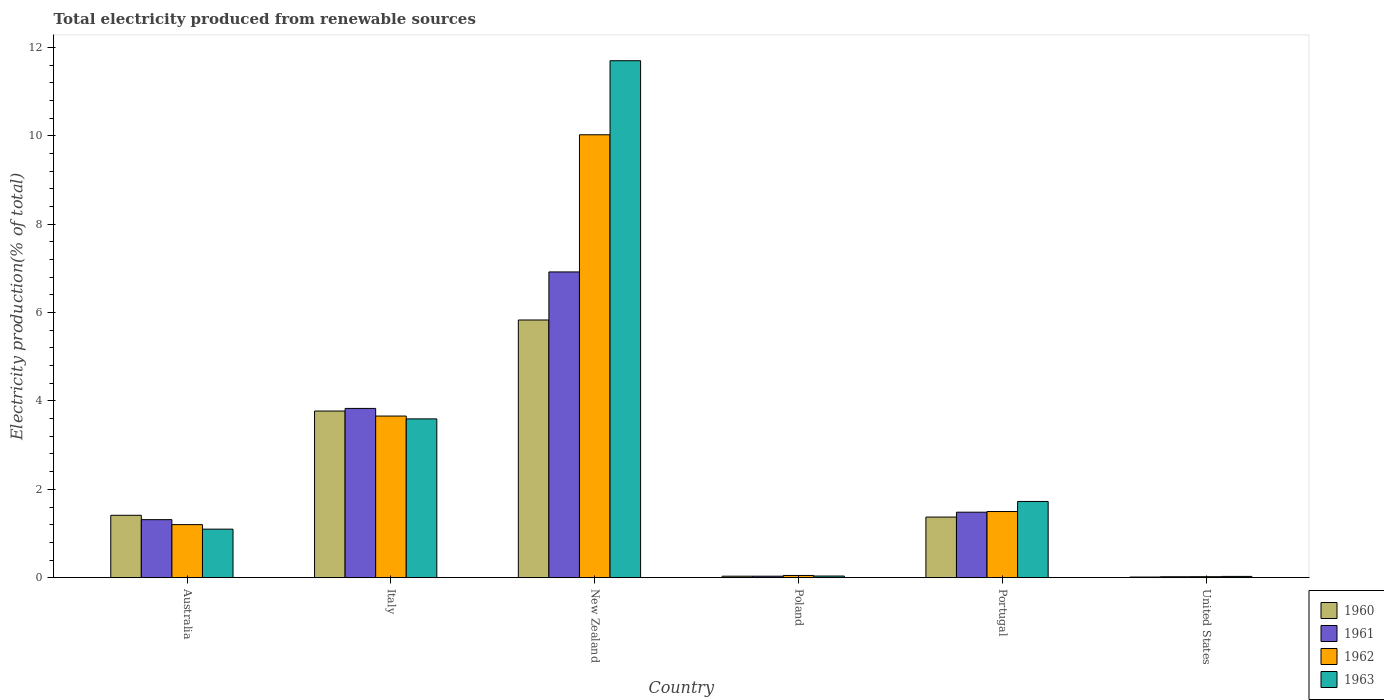How many groups of bars are there?
Offer a very short reply. 6. Are the number of bars per tick equal to the number of legend labels?
Offer a very short reply. Yes. How many bars are there on the 2nd tick from the left?
Provide a succinct answer. 4. In how many cases, is the number of bars for a given country not equal to the number of legend labels?
Keep it short and to the point. 0. What is the total electricity produced in 1962 in Poland?
Keep it short and to the point. 0.05. Across all countries, what is the maximum total electricity produced in 1963?
Provide a succinct answer. 11.7. Across all countries, what is the minimum total electricity produced in 1960?
Offer a terse response. 0.02. In which country was the total electricity produced in 1963 maximum?
Provide a short and direct response. New Zealand. In which country was the total electricity produced in 1962 minimum?
Your response must be concise. United States. What is the total total electricity produced in 1960 in the graph?
Make the answer very short. 12.44. What is the difference between the total electricity produced in 1963 in Poland and that in Portugal?
Provide a short and direct response. -1.69. What is the difference between the total electricity produced in 1963 in Poland and the total electricity produced in 1960 in Italy?
Make the answer very short. -3.73. What is the average total electricity produced in 1961 per country?
Your answer should be very brief. 2.27. What is the difference between the total electricity produced of/in 1962 and total electricity produced of/in 1960 in Australia?
Provide a succinct answer. -0.21. In how many countries, is the total electricity produced in 1963 greater than 5.6 %?
Your answer should be very brief. 1. What is the ratio of the total electricity produced in 1961 in Italy to that in Portugal?
Keep it short and to the point. 2.58. Is the total electricity produced in 1960 in Australia less than that in Italy?
Keep it short and to the point. Yes. Is the difference between the total electricity produced in 1962 in Australia and Poland greater than the difference between the total electricity produced in 1960 in Australia and Poland?
Give a very brief answer. No. What is the difference between the highest and the second highest total electricity produced in 1961?
Give a very brief answer. -2.35. What is the difference between the highest and the lowest total electricity produced in 1961?
Your answer should be compact. 6.9. In how many countries, is the total electricity produced in 1960 greater than the average total electricity produced in 1960 taken over all countries?
Keep it short and to the point. 2. Is it the case that in every country, the sum of the total electricity produced in 1963 and total electricity produced in 1961 is greater than the sum of total electricity produced in 1962 and total electricity produced in 1960?
Ensure brevity in your answer.  No. What does the 3rd bar from the left in Poland represents?
Provide a succinct answer. 1962. Is it the case that in every country, the sum of the total electricity produced in 1963 and total electricity produced in 1962 is greater than the total electricity produced in 1960?
Keep it short and to the point. Yes. How many bars are there?
Give a very brief answer. 24. How many countries are there in the graph?
Offer a terse response. 6. Are the values on the major ticks of Y-axis written in scientific E-notation?
Offer a terse response. No. How are the legend labels stacked?
Offer a very short reply. Vertical. What is the title of the graph?
Your answer should be compact. Total electricity produced from renewable sources. What is the label or title of the X-axis?
Provide a succinct answer. Country. What is the label or title of the Y-axis?
Make the answer very short. Electricity production(% of total). What is the Electricity production(% of total) in 1960 in Australia?
Give a very brief answer. 1.41. What is the Electricity production(% of total) in 1961 in Australia?
Offer a terse response. 1.31. What is the Electricity production(% of total) in 1962 in Australia?
Ensure brevity in your answer.  1.2. What is the Electricity production(% of total) in 1963 in Australia?
Your answer should be compact. 1.1. What is the Electricity production(% of total) of 1960 in Italy?
Ensure brevity in your answer.  3.77. What is the Electricity production(% of total) of 1961 in Italy?
Ensure brevity in your answer.  3.83. What is the Electricity production(% of total) of 1962 in Italy?
Your answer should be compact. 3.66. What is the Electricity production(% of total) in 1963 in Italy?
Your answer should be very brief. 3.59. What is the Electricity production(% of total) of 1960 in New Zealand?
Offer a very short reply. 5.83. What is the Electricity production(% of total) of 1961 in New Zealand?
Your answer should be very brief. 6.92. What is the Electricity production(% of total) in 1962 in New Zealand?
Keep it short and to the point. 10.02. What is the Electricity production(% of total) in 1963 in New Zealand?
Give a very brief answer. 11.7. What is the Electricity production(% of total) in 1960 in Poland?
Give a very brief answer. 0.03. What is the Electricity production(% of total) of 1961 in Poland?
Your answer should be compact. 0.03. What is the Electricity production(% of total) of 1962 in Poland?
Offer a terse response. 0.05. What is the Electricity production(% of total) of 1963 in Poland?
Your answer should be very brief. 0.04. What is the Electricity production(% of total) of 1960 in Portugal?
Make the answer very short. 1.37. What is the Electricity production(% of total) in 1961 in Portugal?
Ensure brevity in your answer.  1.48. What is the Electricity production(% of total) in 1962 in Portugal?
Provide a succinct answer. 1.5. What is the Electricity production(% of total) of 1963 in Portugal?
Make the answer very short. 1.73. What is the Electricity production(% of total) of 1960 in United States?
Provide a short and direct response. 0.02. What is the Electricity production(% of total) in 1961 in United States?
Give a very brief answer. 0.02. What is the Electricity production(% of total) of 1962 in United States?
Ensure brevity in your answer.  0.02. What is the Electricity production(% of total) in 1963 in United States?
Ensure brevity in your answer.  0.03. Across all countries, what is the maximum Electricity production(% of total) in 1960?
Keep it short and to the point. 5.83. Across all countries, what is the maximum Electricity production(% of total) in 1961?
Keep it short and to the point. 6.92. Across all countries, what is the maximum Electricity production(% of total) of 1962?
Give a very brief answer. 10.02. Across all countries, what is the maximum Electricity production(% of total) of 1963?
Make the answer very short. 11.7. Across all countries, what is the minimum Electricity production(% of total) in 1960?
Offer a terse response. 0.02. Across all countries, what is the minimum Electricity production(% of total) of 1961?
Offer a very short reply. 0.02. Across all countries, what is the minimum Electricity production(% of total) in 1962?
Your answer should be very brief. 0.02. Across all countries, what is the minimum Electricity production(% of total) of 1963?
Your response must be concise. 0.03. What is the total Electricity production(% of total) in 1960 in the graph?
Provide a short and direct response. 12.44. What is the total Electricity production(% of total) in 1961 in the graph?
Provide a short and direct response. 13.6. What is the total Electricity production(% of total) of 1962 in the graph?
Your answer should be very brief. 16.46. What is the total Electricity production(% of total) of 1963 in the graph?
Your answer should be compact. 18.19. What is the difference between the Electricity production(% of total) in 1960 in Australia and that in Italy?
Your answer should be very brief. -2.36. What is the difference between the Electricity production(% of total) of 1961 in Australia and that in Italy?
Your response must be concise. -2.52. What is the difference between the Electricity production(% of total) of 1962 in Australia and that in Italy?
Your response must be concise. -2.46. What is the difference between the Electricity production(% of total) of 1963 in Australia and that in Italy?
Ensure brevity in your answer.  -2.5. What is the difference between the Electricity production(% of total) of 1960 in Australia and that in New Zealand?
Keep it short and to the point. -4.42. What is the difference between the Electricity production(% of total) of 1961 in Australia and that in New Zealand?
Make the answer very short. -5.61. What is the difference between the Electricity production(% of total) in 1962 in Australia and that in New Zealand?
Keep it short and to the point. -8.82. What is the difference between the Electricity production(% of total) in 1963 in Australia and that in New Zealand?
Your response must be concise. -10.6. What is the difference between the Electricity production(% of total) of 1960 in Australia and that in Poland?
Your answer should be very brief. 1.38. What is the difference between the Electricity production(% of total) in 1961 in Australia and that in Poland?
Offer a very short reply. 1.28. What is the difference between the Electricity production(% of total) in 1962 in Australia and that in Poland?
Your answer should be very brief. 1.15. What is the difference between the Electricity production(% of total) of 1963 in Australia and that in Poland?
Your answer should be compact. 1.06. What is the difference between the Electricity production(% of total) in 1960 in Australia and that in Portugal?
Provide a succinct answer. 0.04. What is the difference between the Electricity production(% of total) in 1961 in Australia and that in Portugal?
Your response must be concise. -0.17. What is the difference between the Electricity production(% of total) in 1962 in Australia and that in Portugal?
Offer a very short reply. -0.3. What is the difference between the Electricity production(% of total) of 1963 in Australia and that in Portugal?
Your answer should be very brief. -0.63. What is the difference between the Electricity production(% of total) of 1960 in Australia and that in United States?
Ensure brevity in your answer.  1.4. What is the difference between the Electricity production(% of total) of 1961 in Australia and that in United States?
Provide a short and direct response. 1.29. What is the difference between the Electricity production(% of total) of 1962 in Australia and that in United States?
Ensure brevity in your answer.  1.18. What is the difference between the Electricity production(% of total) of 1963 in Australia and that in United States?
Offer a terse response. 1.07. What is the difference between the Electricity production(% of total) in 1960 in Italy and that in New Zealand?
Your answer should be very brief. -2.06. What is the difference between the Electricity production(% of total) in 1961 in Italy and that in New Zealand?
Provide a short and direct response. -3.09. What is the difference between the Electricity production(% of total) of 1962 in Italy and that in New Zealand?
Provide a succinct answer. -6.37. What is the difference between the Electricity production(% of total) in 1963 in Italy and that in New Zealand?
Ensure brevity in your answer.  -8.11. What is the difference between the Electricity production(% of total) of 1960 in Italy and that in Poland?
Your answer should be compact. 3.74. What is the difference between the Electricity production(% of total) of 1961 in Italy and that in Poland?
Keep it short and to the point. 3.8. What is the difference between the Electricity production(% of total) of 1962 in Italy and that in Poland?
Provide a short and direct response. 3.61. What is the difference between the Electricity production(% of total) in 1963 in Italy and that in Poland?
Make the answer very short. 3.56. What is the difference between the Electricity production(% of total) of 1960 in Italy and that in Portugal?
Your answer should be compact. 2.4. What is the difference between the Electricity production(% of total) in 1961 in Italy and that in Portugal?
Your response must be concise. 2.35. What is the difference between the Electricity production(% of total) in 1962 in Italy and that in Portugal?
Provide a succinct answer. 2.16. What is the difference between the Electricity production(% of total) of 1963 in Italy and that in Portugal?
Provide a succinct answer. 1.87. What is the difference between the Electricity production(% of total) of 1960 in Italy and that in United States?
Your response must be concise. 3.76. What is the difference between the Electricity production(% of total) of 1961 in Italy and that in United States?
Provide a succinct answer. 3.81. What is the difference between the Electricity production(% of total) of 1962 in Italy and that in United States?
Make the answer very short. 3.64. What is the difference between the Electricity production(% of total) of 1963 in Italy and that in United States?
Offer a very short reply. 3.56. What is the difference between the Electricity production(% of total) in 1960 in New Zealand and that in Poland?
Provide a short and direct response. 5.8. What is the difference between the Electricity production(% of total) of 1961 in New Zealand and that in Poland?
Offer a very short reply. 6.89. What is the difference between the Electricity production(% of total) of 1962 in New Zealand and that in Poland?
Provide a short and direct response. 9.97. What is the difference between the Electricity production(% of total) of 1963 in New Zealand and that in Poland?
Offer a very short reply. 11.66. What is the difference between the Electricity production(% of total) of 1960 in New Zealand and that in Portugal?
Offer a very short reply. 4.46. What is the difference between the Electricity production(% of total) in 1961 in New Zealand and that in Portugal?
Your response must be concise. 5.44. What is the difference between the Electricity production(% of total) in 1962 in New Zealand and that in Portugal?
Keep it short and to the point. 8.53. What is the difference between the Electricity production(% of total) of 1963 in New Zealand and that in Portugal?
Your answer should be very brief. 9.97. What is the difference between the Electricity production(% of total) in 1960 in New Zealand and that in United States?
Provide a succinct answer. 5.82. What is the difference between the Electricity production(% of total) of 1961 in New Zealand and that in United States?
Provide a succinct answer. 6.9. What is the difference between the Electricity production(% of total) of 1962 in New Zealand and that in United States?
Provide a short and direct response. 10. What is the difference between the Electricity production(% of total) of 1963 in New Zealand and that in United States?
Provide a short and direct response. 11.67. What is the difference between the Electricity production(% of total) in 1960 in Poland and that in Portugal?
Your response must be concise. -1.34. What is the difference between the Electricity production(% of total) of 1961 in Poland and that in Portugal?
Provide a short and direct response. -1.45. What is the difference between the Electricity production(% of total) of 1962 in Poland and that in Portugal?
Your answer should be very brief. -1.45. What is the difference between the Electricity production(% of total) in 1963 in Poland and that in Portugal?
Provide a short and direct response. -1.69. What is the difference between the Electricity production(% of total) in 1960 in Poland and that in United States?
Your response must be concise. 0.02. What is the difference between the Electricity production(% of total) in 1961 in Poland and that in United States?
Provide a short and direct response. 0.01. What is the difference between the Electricity production(% of total) of 1962 in Poland and that in United States?
Your answer should be very brief. 0.03. What is the difference between the Electricity production(% of total) in 1963 in Poland and that in United States?
Your response must be concise. 0.01. What is the difference between the Electricity production(% of total) in 1960 in Portugal and that in United States?
Your response must be concise. 1.36. What is the difference between the Electricity production(% of total) of 1961 in Portugal and that in United States?
Your response must be concise. 1.46. What is the difference between the Electricity production(% of total) of 1962 in Portugal and that in United States?
Ensure brevity in your answer.  1.48. What is the difference between the Electricity production(% of total) in 1963 in Portugal and that in United States?
Your response must be concise. 1.7. What is the difference between the Electricity production(% of total) of 1960 in Australia and the Electricity production(% of total) of 1961 in Italy?
Provide a succinct answer. -2.42. What is the difference between the Electricity production(% of total) in 1960 in Australia and the Electricity production(% of total) in 1962 in Italy?
Your answer should be very brief. -2.25. What is the difference between the Electricity production(% of total) in 1960 in Australia and the Electricity production(% of total) in 1963 in Italy?
Keep it short and to the point. -2.18. What is the difference between the Electricity production(% of total) of 1961 in Australia and the Electricity production(% of total) of 1962 in Italy?
Offer a terse response. -2.34. What is the difference between the Electricity production(% of total) of 1961 in Australia and the Electricity production(% of total) of 1963 in Italy?
Your answer should be compact. -2.28. What is the difference between the Electricity production(% of total) in 1962 in Australia and the Electricity production(% of total) in 1963 in Italy?
Provide a short and direct response. -2.39. What is the difference between the Electricity production(% of total) in 1960 in Australia and the Electricity production(% of total) in 1961 in New Zealand?
Provide a succinct answer. -5.51. What is the difference between the Electricity production(% of total) in 1960 in Australia and the Electricity production(% of total) in 1962 in New Zealand?
Keep it short and to the point. -8.61. What is the difference between the Electricity production(% of total) in 1960 in Australia and the Electricity production(% of total) in 1963 in New Zealand?
Provide a succinct answer. -10.29. What is the difference between the Electricity production(% of total) of 1961 in Australia and the Electricity production(% of total) of 1962 in New Zealand?
Give a very brief answer. -8.71. What is the difference between the Electricity production(% of total) of 1961 in Australia and the Electricity production(% of total) of 1963 in New Zealand?
Keep it short and to the point. -10.39. What is the difference between the Electricity production(% of total) of 1962 in Australia and the Electricity production(% of total) of 1963 in New Zealand?
Offer a very short reply. -10.5. What is the difference between the Electricity production(% of total) in 1960 in Australia and the Electricity production(% of total) in 1961 in Poland?
Offer a very short reply. 1.38. What is the difference between the Electricity production(% of total) in 1960 in Australia and the Electricity production(% of total) in 1962 in Poland?
Ensure brevity in your answer.  1.36. What is the difference between the Electricity production(% of total) of 1960 in Australia and the Electricity production(% of total) of 1963 in Poland?
Ensure brevity in your answer.  1.37. What is the difference between the Electricity production(% of total) in 1961 in Australia and the Electricity production(% of total) in 1962 in Poland?
Keep it short and to the point. 1.26. What is the difference between the Electricity production(% of total) in 1961 in Australia and the Electricity production(% of total) in 1963 in Poland?
Your response must be concise. 1.28. What is the difference between the Electricity production(% of total) in 1962 in Australia and the Electricity production(% of total) in 1963 in Poland?
Provide a short and direct response. 1.16. What is the difference between the Electricity production(% of total) of 1960 in Australia and the Electricity production(% of total) of 1961 in Portugal?
Keep it short and to the point. -0.07. What is the difference between the Electricity production(% of total) in 1960 in Australia and the Electricity production(% of total) in 1962 in Portugal?
Give a very brief answer. -0.09. What is the difference between the Electricity production(% of total) of 1960 in Australia and the Electricity production(% of total) of 1963 in Portugal?
Your response must be concise. -0.31. What is the difference between the Electricity production(% of total) in 1961 in Australia and the Electricity production(% of total) in 1962 in Portugal?
Ensure brevity in your answer.  -0.18. What is the difference between the Electricity production(% of total) of 1961 in Australia and the Electricity production(% of total) of 1963 in Portugal?
Provide a succinct answer. -0.41. What is the difference between the Electricity production(% of total) in 1962 in Australia and the Electricity production(% of total) in 1963 in Portugal?
Provide a short and direct response. -0.52. What is the difference between the Electricity production(% of total) in 1960 in Australia and the Electricity production(% of total) in 1961 in United States?
Provide a short and direct response. 1.39. What is the difference between the Electricity production(% of total) of 1960 in Australia and the Electricity production(% of total) of 1962 in United States?
Offer a terse response. 1.39. What is the difference between the Electricity production(% of total) in 1960 in Australia and the Electricity production(% of total) in 1963 in United States?
Keep it short and to the point. 1.38. What is the difference between the Electricity production(% of total) in 1961 in Australia and the Electricity production(% of total) in 1962 in United States?
Provide a succinct answer. 1.29. What is the difference between the Electricity production(% of total) of 1961 in Australia and the Electricity production(% of total) of 1963 in United States?
Offer a terse response. 1.28. What is the difference between the Electricity production(% of total) in 1962 in Australia and the Electricity production(% of total) in 1963 in United States?
Keep it short and to the point. 1.17. What is the difference between the Electricity production(% of total) of 1960 in Italy and the Electricity production(% of total) of 1961 in New Zealand?
Make the answer very short. -3.15. What is the difference between the Electricity production(% of total) in 1960 in Italy and the Electricity production(% of total) in 1962 in New Zealand?
Ensure brevity in your answer.  -6.25. What is the difference between the Electricity production(% of total) in 1960 in Italy and the Electricity production(% of total) in 1963 in New Zealand?
Offer a very short reply. -7.93. What is the difference between the Electricity production(% of total) of 1961 in Italy and the Electricity production(% of total) of 1962 in New Zealand?
Provide a short and direct response. -6.19. What is the difference between the Electricity production(% of total) in 1961 in Italy and the Electricity production(% of total) in 1963 in New Zealand?
Keep it short and to the point. -7.87. What is the difference between the Electricity production(% of total) of 1962 in Italy and the Electricity production(% of total) of 1963 in New Zealand?
Make the answer very short. -8.04. What is the difference between the Electricity production(% of total) of 1960 in Italy and the Electricity production(% of total) of 1961 in Poland?
Your response must be concise. 3.74. What is the difference between the Electricity production(% of total) in 1960 in Italy and the Electricity production(% of total) in 1962 in Poland?
Your response must be concise. 3.72. What is the difference between the Electricity production(% of total) in 1960 in Italy and the Electricity production(% of total) in 1963 in Poland?
Make the answer very short. 3.73. What is the difference between the Electricity production(% of total) in 1961 in Italy and the Electricity production(% of total) in 1962 in Poland?
Your response must be concise. 3.78. What is the difference between the Electricity production(% of total) in 1961 in Italy and the Electricity production(% of total) in 1963 in Poland?
Your answer should be very brief. 3.79. What is the difference between the Electricity production(% of total) in 1962 in Italy and the Electricity production(% of total) in 1963 in Poland?
Offer a terse response. 3.62. What is the difference between the Electricity production(% of total) of 1960 in Italy and the Electricity production(% of total) of 1961 in Portugal?
Ensure brevity in your answer.  2.29. What is the difference between the Electricity production(% of total) of 1960 in Italy and the Electricity production(% of total) of 1962 in Portugal?
Make the answer very short. 2.27. What is the difference between the Electricity production(% of total) in 1960 in Italy and the Electricity production(% of total) in 1963 in Portugal?
Keep it short and to the point. 2.05. What is the difference between the Electricity production(% of total) in 1961 in Italy and the Electricity production(% of total) in 1962 in Portugal?
Provide a succinct answer. 2.33. What is the difference between the Electricity production(% of total) of 1961 in Italy and the Electricity production(% of total) of 1963 in Portugal?
Offer a terse response. 2.11. What is the difference between the Electricity production(% of total) of 1962 in Italy and the Electricity production(% of total) of 1963 in Portugal?
Give a very brief answer. 1.93. What is the difference between the Electricity production(% of total) of 1960 in Italy and the Electricity production(% of total) of 1961 in United States?
Offer a terse response. 3.75. What is the difference between the Electricity production(% of total) in 1960 in Italy and the Electricity production(% of total) in 1962 in United States?
Your answer should be compact. 3.75. What is the difference between the Electricity production(% of total) in 1960 in Italy and the Electricity production(% of total) in 1963 in United States?
Give a very brief answer. 3.74. What is the difference between the Electricity production(% of total) in 1961 in Italy and the Electricity production(% of total) in 1962 in United States?
Provide a succinct answer. 3.81. What is the difference between the Electricity production(% of total) of 1961 in Italy and the Electricity production(% of total) of 1963 in United States?
Make the answer very short. 3.8. What is the difference between the Electricity production(% of total) in 1962 in Italy and the Electricity production(% of total) in 1963 in United States?
Offer a very short reply. 3.63. What is the difference between the Electricity production(% of total) in 1960 in New Zealand and the Electricity production(% of total) in 1961 in Poland?
Make the answer very short. 5.8. What is the difference between the Electricity production(% of total) in 1960 in New Zealand and the Electricity production(% of total) in 1962 in Poland?
Offer a terse response. 5.78. What is the difference between the Electricity production(% of total) of 1960 in New Zealand and the Electricity production(% of total) of 1963 in Poland?
Keep it short and to the point. 5.79. What is the difference between the Electricity production(% of total) of 1961 in New Zealand and the Electricity production(% of total) of 1962 in Poland?
Provide a short and direct response. 6.87. What is the difference between the Electricity production(% of total) of 1961 in New Zealand and the Electricity production(% of total) of 1963 in Poland?
Provide a short and direct response. 6.88. What is the difference between the Electricity production(% of total) of 1962 in New Zealand and the Electricity production(% of total) of 1963 in Poland?
Ensure brevity in your answer.  9.99. What is the difference between the Electricity production(% of total) of 1960 in New Zealand and the Electricity production(% of total) of 1961 in Portugal?
Your response must be concise. 4.35. What is the difference between the Electricity production(% of total) of 1960 in New Zealand and the Electricity production(% of total) of 1962 in Portugal?
Your response must be concise. 4.33. What is the difference between the Electricity production(% of total) in 1960 in New Zealand and the Electricity production(% of total) in 1963 in Portugal?
Your answer should be very brief. 4.11. What is the difference between the Electricity production(% of total) in 1961 in New Zealand and the Electricity production(% of total) in 1962 in Portugal?
Ensure brevity in your answer.  5.42. What is the difference between the Electricity production(% of total) of 1961 in New Zealand and the Electricity production(% of total) of 1963 in Portugal?
Offer a terse response. 5.19. What is the difference between the Electricity production(% of total) in 1962 in New Zealand and the Electricity production(% of total) in 1963 in Portugal?
Your answer should be very brief. 8.3. What is the difference between the Electricity production(% of total) in 1960 in New Zealand and the Electricity production(% of total) in 1961 in United States?
Give a very brief answer. 5.81. What is the difference between the Electricity production(% of total) in 1960 in New Zealand and the Electricity production(% of total) in 1962 in United States?
Give a very brief answer. 5.81. What is the difference between the Electricity production(% of total) in 1960 in New Zealand and the Electricity production(% of total) in 1963 in United States?
Make the answer very short. 5.8. What is the difference between the Electricity production(% of total) in 1961 in New Zealand and the Electricity production(% of total) in 1962 in United States?
Ensure brevity in your answer.  6.9. What is the difference between the Electricity production(% of total) in 1961 in New Zealand and the Electricity production(% of total) in 1963 in United States?
Provide a succinct answer. 6.89. What is the difference between the Electricity production(% of total) in 1962 in New Zealand and the Electricity production(% of total) in 1963 in United States?
Offer a terse response. 10. What is the difference between the Electricity production(% of total) in 1960 in Poland and the Electricity production(% of total) in 1961 in Portugal?
Keep it short and to the point. -1.45. What is the difference between the Electricity production(% of total) of 1960 in Poland and the Electricity production(% of total) of 1962 in Portugal?
Keep it short and to the point. -1.46. What is the difference between the Electricity production(% of total) of 1960 in Poland and the Electricity production(% of total) of 1963 in Portugal?
Give a very brief answer. -1.69. What is the difference between the Electricity production(% of total) in 1961 in Poland and the Electricity production(% of total) in 1962 in Portugal?
Make the answer very short. -1.46. What is the difference between the Electricity production(% of total) of 1961 in Poland and the Electricity production(% of total) of 1963 in Portugal?
Your answer should be very brief. -1.69. What is the difference between the Electricity production(% of total) in 1962 in Poland and the Electricity production(% of total) in 1963 in Portugal?
Offer a very short reply. -1.67. What is the difference between the Electricity production(% of total) of 1960 in Poland and the Electricity production(% of total) of 1961 in United States?
Provide a succinct answer. 0.01. What is the difference between the Electricity production(% of total) in 1960 in Poland and the Electricity production(% of total) in 1962 in United States?
Offer a very short reply. 0.01. What is the difference between the Electricity production(% of total) of 1960 in Poland and the Electricity production(% of total) of 1963 in United States?
Your response must be concise. 0. What is the difference between the Electricity production(% of total) of 1961 in Poland and the Electricity production(% of total) of 1962 in United States?
Offer a terse response. 0.01. What is the difference between the Electricity production(% of total) of 1961 in Poland and the Electricity production(% of total) of 1963 in United States?
Provide a succinct answer. 0. What is the difference between the Electricity production(% of total) in 1962 in Poland and the Electricity production(% of total) in 1963 in United States?
Provide a succinct answer. 0.02. What is the difference between the Electricity production(% of total) in 1960 in Portugal and the Electricity production(% of total) in 1961 in United States?
Your response must be concise. 1.35. What is the difference between the Electricity production(% of total) in 1960 in Portugal and the Electricity production(% of total) in 1962 in United States?
Make the answer very short. 1.35. What is the difference between the Electricity production(% of total) of 1960 in Portugal and the Electricity production(% of total) of 1963 in United States?
Provide a succinct answer. 1.34. What is the difference between the Electricity production(% of total) in 1961 in Portugal and the Electricity production(% of total) in 1962 in United States?
Give a very brief answer. 1.46. What is the difference between the Electricity production(% of total) in 1961 in Portugal and the Electricity production(% of total) in 1963 in United States?
Make the answer very short. 1.45. What is the difference between the Electricity production(% of total) in 1962 in Portugal and the Electricity production(% of total) in 1963 in United States?
Your answer should be compact. 1.47. What is the average Electricity production(% of total) of 1960 per country?
Your answer should be compact. 2.07. What is the average Electricity production(% of total) of 1961 per country?
Keep it short and to the point. 2.27. What is the average Electricity production(% of total) of 1962 per country?
Your answer should be compact. 2.74. What is the average Electricity production(% of total) in 1963 per country?
Ensure brevity in your answer.  3.03. What is the difference between the Electricity production(% of total) in 1960 and Electricity production(% of total) in 1961 in Australia?
Offer a terse response. 0.1. What is the difference between the Electricity production(% of total) of 1960 and Electricity production(% of total) of 1962 in Australia?
Provide a succinct answer. 0.21. What is the difference between the Electricity production(% of total) of 1960 and Electricity production(% of total) of 1963 in Australia?
Provide a succinct answer. 0.31. What is the difference between the Electricity production(% of total) in 1961 and Electricity production(% of total) in 1962 in Australia?
Offer a terse response. 0.11. What is the difference between the Electricity production(% of total) of 1961 and Electricity production(% of total) of 1963 in Australia?
Your answer should be compact. 0.21. What is the difference between the Electricity production(% of total) of 1962 and Electricity production(% of total) of 1963 in Australia?
Provide a short and direct response. 0.1. What is the difference between the Electricity production(% of total) in 1960 and Electricity production(% of total) in 1961 in Italy?
Your response must be concise. -0.06. What is the difference between the Electricity production(% of total) in 1960 and Electricity production(% of total) in 1962 in Italy?
Your answer should be very brief. 0.11. What is the difference between the Electricity production(% of total) of 1960 and Electricity production(% of total) of 1963 in Italy?
Your answer should be compact. 0.18. What is the difference between the Electricity production(% of total) in 1961 and Electricity production(% of total) in 1962 in Italy?
Offer a terse response. 0.17. What is the difference between the Electricity production(% of total) in 1961 and Electricity production(% of total) in 1963 in Italy?
Give a very brief answer. 0.24. What is the difference between the Electricity production(% of total) in 1962 and Electricity production(% of total) in 1963 in Italy?
Provide a succinct answer. 0.06. What is the difference between the Electricity production(% of total) in 1960 and Electricity production(% of total) in 1961 in New Zealand?
Provide a short and direct response. -1.09. What is the difference between the Electricity production(% of total) in 1960 and Electricity production(% of total) in 1962 in New Zealand?
Provide a succinct answer. -4.19. What is the difference between the Electricity production(% of total) of 1960 and Electricity production(% of total) of 1963 in New Zealand?
Give a very brief answer. -5.87. What is the difference between the Electricity production(% of total) in 1961 and Electricity production(% of total) in 1962 in New Zealand?
Give a very brief answer. -3.1. What is the difference between the Electricity production(% of total) of 1961 and Electricity production(% of total) of 1963 in New Zealand?
Provide a short and direct response. -4.78. What is the difference between the Electricity production(% of total) of 1962 and Electricity production(% of total) of 1963 in New Zealand?
Your answer should be compact. -1.68. What is the difference between the Electricity production(% of total) of 1960 and Electricity production(% of total) of 1962 in Poland?
Offer a very short reply. -0.02. What is the difference between the Electricity production(% of total) of 1960 and Electricity production(% of total) of 1963 in Poland?
Make the answer very short. -0. What is the difference between the Electricity production(% of total) in 1961 and Electricity production(% of total) in 1962 in Poland?
Provide a short and direct response. -0.02. What is the difference between the Electricity production(% of total) of 1961 and Electricity production(% of total) of 1963 in Poland?
Keep it short and to the point. -0. What is the difference between the Electricity production(% of total) in 1962 and Electricity production(% of total) in 1963 in Poland?
Give a very brief answer. 0.01. What is the difference between the Electricity production(% of total) in 1960 and Electricity production(% of total) in 1961 in Portugal?
Ensure brevity in your answer.  -0.11. What is the difference between the Electricity production(% of total) of 1960 and Electricity production(% of total) of 1962 in Portugal?
Offer a terse response. -0.13. What is the difference between the Electricity production(% of total) in 1960 and Electricity production(% of total) in 1963 in Portugal?
Offer a very short reply. -0.35. What is the difference between the Electricity production(% of total) of 1961 and Electricity production(% of total) of 1962 in Portugal?
Your answer should be very brief. -0.02. What is the difference between the Electricity production(% of total) of 1961 and Electricity production(% of total) of 1963 in Portugal?
Offer a very short reply. -0.24. What is the difference between the Electricity production(% of total) of 1962 and Electricity production(% of total) of 1963 in Portugal?
Your answer should be compact. -0.23. What is the difference between the Electricity production(% of total) in 1960 and Electricity production(% of total) in 1961 in United States?
Offer a very short reply. -0.01. What is the difference between the Electricity production(% of total) of 1960 and Electricity production(% of total) of 1962 in United States?
Provide a succinct answer. -0.01. What is the difference between the Electricity production(% of total) of 1960 and Electricity production(% of total) of 1963 in United States?
Give a very brief answer. -0.01. What is the difference between the Electricity production(% of total) of 1961 and Electricity production(% of total) of 1962 in United States?
Your response must be concise. -0. What is the difference between the Electricity production(% of total) of 1961 and Electricity production(% of total) of 1963 in United States?
Your answer should be compact. -0.01. What is the difference between the Electricity production(% of total) of 1962 and Electricity production(% of total) of 1963 in United States?
Your response must be concise. -0.01. What is the ratio of the Electricity production(% of total) in 1960 in Australia to that in Italy?
Give a very brief answer. 0.37. What is the ratio of the Electricity production(% of total) of 1961 in Australia to that in Italy?
Keep it short and to the point. 0.34. What is the ratio of the Electricity production(% of total) in 1962 in Australia to that in Italy?
Give a very brief answer. 0.33. What is the ratio of the Electricity production(% of total) in 1963 in Australia to that in Italy?
Offer a very short reply. 0.31. What is the ratio of the Electricity production(% of total) of 1960 in Australia to that in New Zealand?
Provide a short and direct response. 0.24. What is the ratio of the Electricity production(% of total) of 1961 in Australia to that in New Zealand?
Your response must be concise. 0.19. What is the ratio of the Electricity production(% of total) in 1962 in Australia to that in New Zealand?
Ensure brevity in your answer.  0.12. What is the ratio of the Electricity production(% of total) of 1963 in Australia to that in New Zealand?
Your answer should be compact. 0.09. What is the ratio of the Electricity production(% of total) in 1960 in Australia to that in Poland?
Your response must be concise. 41.37. What is the ratio of the Electricity production(% of total) in 1961 in Australia to that in Poland?
Your response must be concise. 38.51. What is the ratio of the Electricity production(% of total) of 1962 in Australia to that in Poland?
Your answer should be compact. 23.61. What is the ratio of the Electricity production(% of total) in 1963 in Australia to that in Poland?
Your answer should be very brief. 29. What is the ratio of the Electricity production(% of total) in 1960 in Australia to that in Portugal?
Ensure brevity in your answer.  1.03. What is the ratio of the Electricity production(% of total) in 1961 in Australia to that in Portugal?
Ensure brevity in your answer.  0.89. What is the ratio of the Electricity production(% of total) in 1962 in Australia to that in Portugal?
Offer a terse response. 0.8. What is the ratio of the Electricity production(% of total) in 1963 in Australia to that in Portugal?
Provide a succinct answer. 0.64. What is the ratio of the Electricity production(% of total) of 1960 in Australia to that in United States?
Your answer should be compact. 92.6. What is the ratio of the Electricity production(% of total) in 1961 in Australia to that in United States?
Give a very brief answer. 61. What is the ratio of the Electricity production(% of total) in 1962 in Australia to that in United States?
Ensure brevity in your answer.  52.74. What is the ratio of the Electricity production(% of total) in 1963 in Australia to that in United States?
Provide a short and direct response. 37.34. What is the ratio of the Electricity production(% of total) of 1960 in Italy to that in New Zealand?
Ensure brevity in your answer.  0.65. What is the ratio of the Electricity production(% of total) in 1961 in Italy to that in New Zealand?
Keep it short and to the point. 0.55. What is the ratio of the Electricity production(% of total) of 1962 in Italy to that in New Zealand?
Your answer should be compact. 0.36. What is the ratio of the Electricity production(% of total) of 1963 in Italy to that in New Zealand?
Offer a very short reply. 0.31. What is the ratio of the Electricity production(% of total) in 1960 in Italy to that in Poland?
Ensure brevity in your answer.  110.45. What is the ratio of the Electricity production(% of total) of 1961 in Italy to that in Poland?
Your response must be concise. 112.3. What is the ratio of the Electricity production(% of total) of 1962 in Italy to that in Poland?
Your response must be concise. 71.88. What is the ratio of the Electricity production(% of total) in 1963 in Italy to that in Poland?
Offer a very short reply. 94.84. What is the ratio of the Electricity production(% of total) in 1960 in Italy to that in Portugal?
Keep it short and to the point. 2.75. What is the ratio of the Electricity production(% of total) in 1961 in Italy to that in Portugal?
Ensure brevity in your answer.  2.58. What is the ratio of the Electricity production(% of total) in 1962 in Italy to that in Portugal?
Your response must be concise. 2.44. What is the ratio of the Electricity production(% of total) in 1963 in Italy to that in Portugal?
Offer a very short reply. 2.08. What is the ratio of the Electricity production(% of total) in 1960 in Italy to that in United States?
Your answer should be compact. 247.25. What is the ratio of the Electricity production(% of total) of 1961 in Italy to that in United States?
Give a very brief answer. 177.87. What is the ratio of the Electricity production(% of total) of 1962 in Italy to that in United States?
Offer a very short reply. 160.56. What is the ratio of the Electricity production(% of total) of 1963 in Italy to that in United States?
Ensure brevity in your answer.  122.12. What is the ratio of the Electricity production(% of total) in 1960 in New Zealand to that in Poland?
Give a very brief answer. 170.79. What is the ratio of the Electricity production(% of total) of 1961 in New Zealand to that in Poland?
Provide a succinct answer. 202.83. What is the ratio of the Electricity production(% of total) in 1962 in New Zealand to that in Poland?
Offer a terse response. 196.95. What is the ratio of the Electricity production(% of total) in 1963 in New Zealand to that in Poland?
Provide a succinct answer. 308.73. What is the ratio of the Electricity production(% of total) of 1960 in New Zealand to that in Portugal?
Offer a terse response. 4.25. What is the ratio of the Electricity production(% of total) of 1961 in New Zealand to that in Portugal?
Ensure brevity in your answer.  4.67. What is the ratio of the Electricity production(% of total) in 1962 in New Zealand to that in Portugal?
Your answer should be compact. 6.69. What is the ratio of the Electricity production(% of total) of 1963 in New Zealand to that in Portugal?
Your answer should be very brief. 6.78. What is the ratio of the Electricity production(% of total) in 1960 in New Zealand to that in United States?
Offer a terse response. 382.31. What is the ratio of the Electricity production(% of total) of 1961 in New Zealand to that in United States?
Offer a very short reply. 321.25. What is the ratio of the Electricity production(% of total) of 1962 in New Zealand to that in United States?
Provide a short and direct response. 439.93. What is the ratio of the Electricity production(% of total) in 1963 in New Zealand to that in United States?
Your response must be concise. 397.5. What is the ratio of the Electricity production(% of total) in 1960 in Poland to that in Portugal?
Offer a very short reply. 0.02. What is the ratio of the Electricity production(% of total) of 1961 in Poland to that in Portugal?
Offer a terse response. 0.02. What is the ratio of the Electricity production(% of total) in 1962 in Poland to that in Portugal?
Ensure brevity in your answer.  0.03. What is the ratio of the Electricity production(% of total) of 1963 in Poland to that in Portugal?
Offer a very short reply. 0.02. What is the ratio of the Electricity production(% of total) in 1960 in Poland to that in United States?
Provide a succinct answer. 2.24. What is the ratio of the Electricity production(% of total) of 1961 in Poland to that in United States?
Give a very brief answer. 1.58. What is the ratio of the Electricity production(% of total) in 1962 in Poland to that in United States?
Ensure brevity in your answer.  2.23. What is the ratio of the Electricity production(% of total) in 1963 in Poland to that in United States?
Provide a short and direct response. 1.29. What is the ratio of the Electricity production(% of total) in 1960 in Portugal to that in United States?
Your answer should be very brief. 89.96. What is the ratio of the Electricity production(% of total) of 1961 in Portugal to that in United States?
Give a very brief answer. 68.83. What is the ratio of the Electricity production(% of total) of 1962 in Portugal to that in United States?
Your response must be concise. 65.74. What is the ratio of the Electricity production(% of total) in 1963 in Portugal to that in United States?
Your answer should be very brief. 58.63. What is the difference between the highest and the second highest Electricity production(% of total) of 1960?
Offer a terse response. 2.06. What is the difference between the highest and the second highest Electricity production(% of total) of 1961?
Your answer should be very brief. 3.09. What is the difference between the highest and the second highest Electricity production(% of total) of 1962?
Ensure brevity in your answer.  6.37. What is the difference between the highest and the second highest Electricity production(% of total) of 1963?
Provide a succinct answer. 8.11. What is the difference between the highest and the lowest Electricity production(% of total) in 1960?
Ensure brevity in your answer.  5.82. What is the difference between the highest and the lowest Electricity production(% of total) of 1961?
Offer a terse response. 6.9. What is the difference between the highest and the lowest Electricity production(% of total) of 1962?
Make the answer very short. 10. What is the difference between the highest and the lowest Electricity production(% of total) in 1963?
Keep it short and to the point. 11.67. 